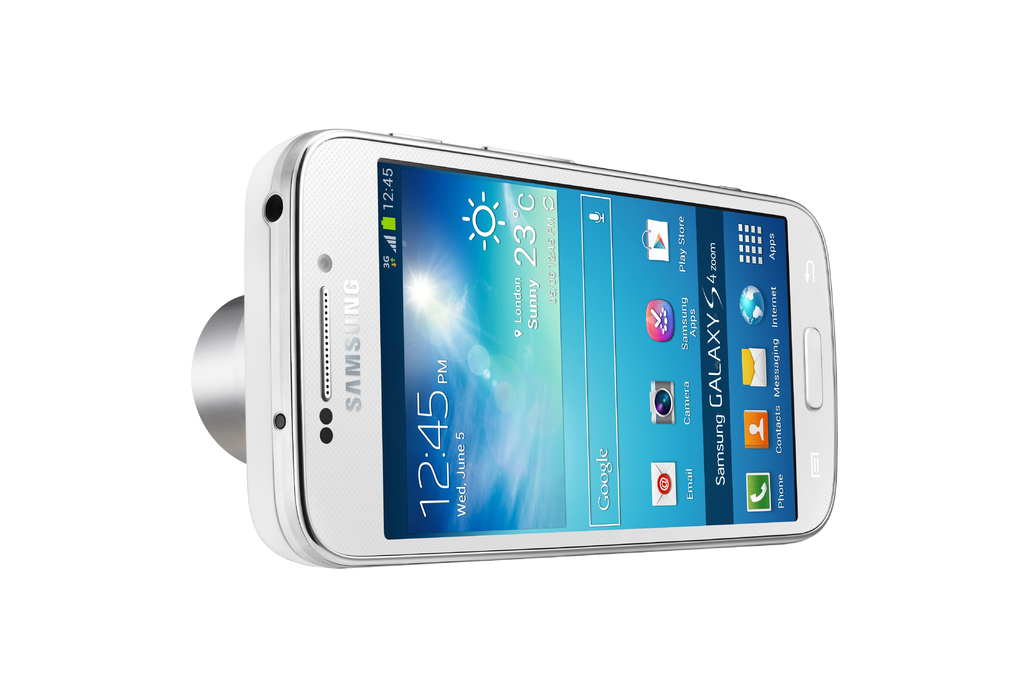Provide a one-sentence caption for the provided image. The image shows a Samsung Galaxy S 4 smartphone, powered on and displaying a vibrant screen with weather details and essential apps, indicating a user-friendly interface designed for everyday convenience. 